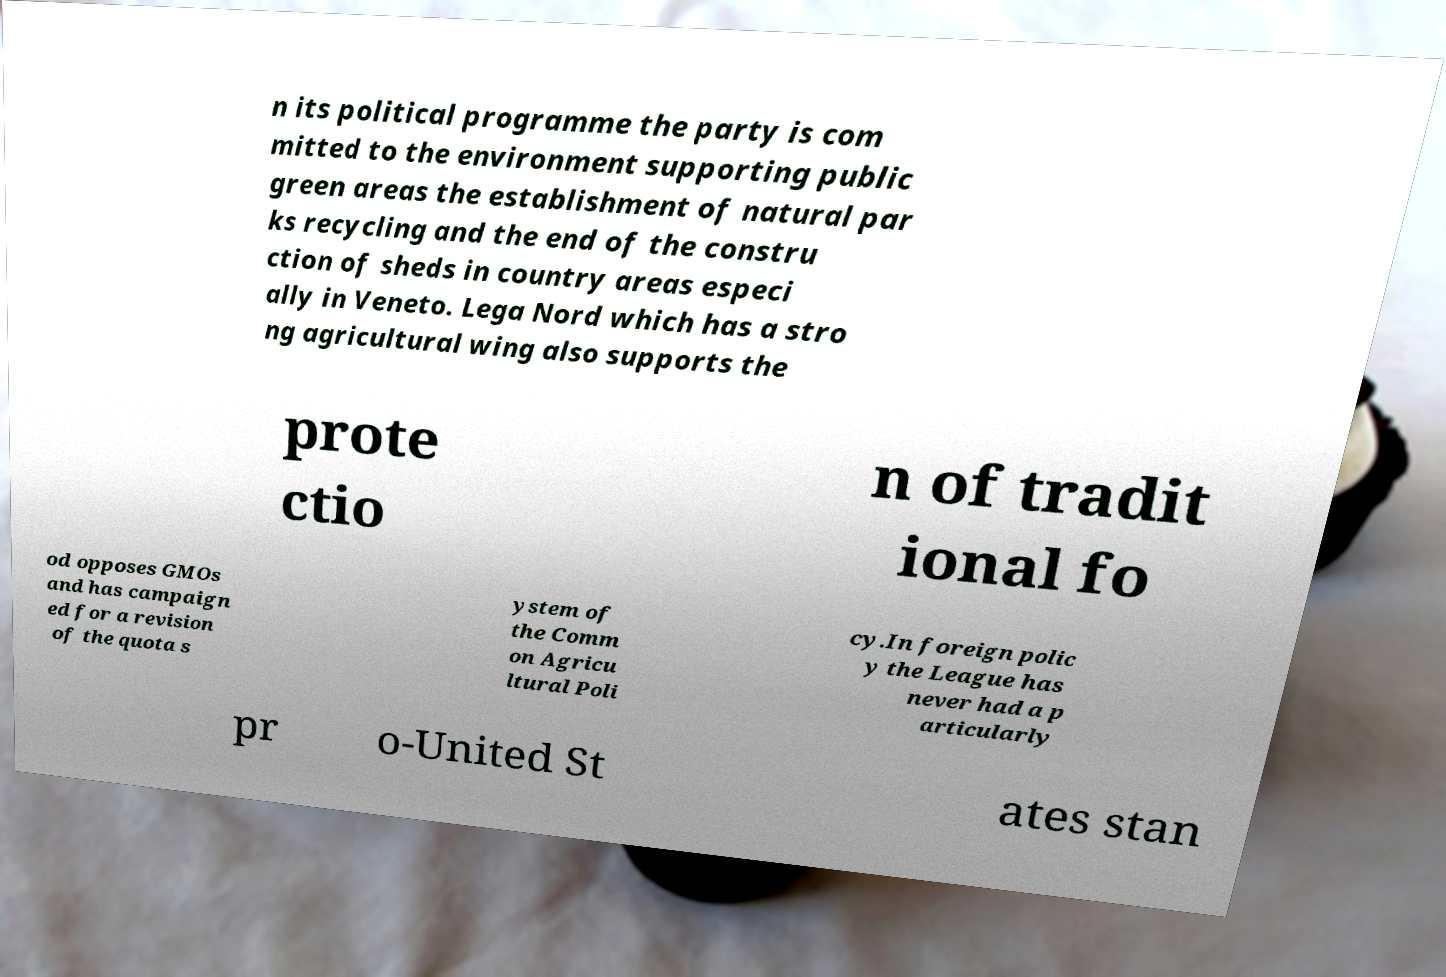Could you assist in decoding the text presented in this image and type it out clearly? n its political programme the party is com mitted to the environment supporting public green areas the establishment of natural par ks recycling and the end of the constru ction of sheds in country areas especi ally in Veneto. Lega Nord which has a stro ng agricultural wing also supports the prote ctio n of tradit ional fo od opposes GMOs and has campaign ed for a revision of the quota s ystem of the Comm on Agricu ltural Poli cy.In foreign polic y the League has never had a p articularly pr o-United St ates stan 